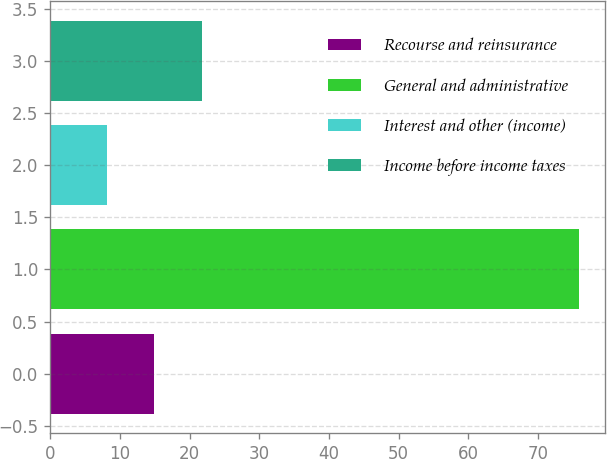Convert chart. <chart><loc_0><loc_0><loc_500><loc_500><bar_chart><fcel>Recourse and reinsurance<fcel>General and administrative<fcel>Interest and other (income)<fcel>Income before income taxes<nl><fcel>14.96<fcel>75.8<fcel>8.2<fcel>21.72<nl></chart> 